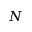<formula> <loc_0><loc_0><loc_500><loc_500>N</formula> 